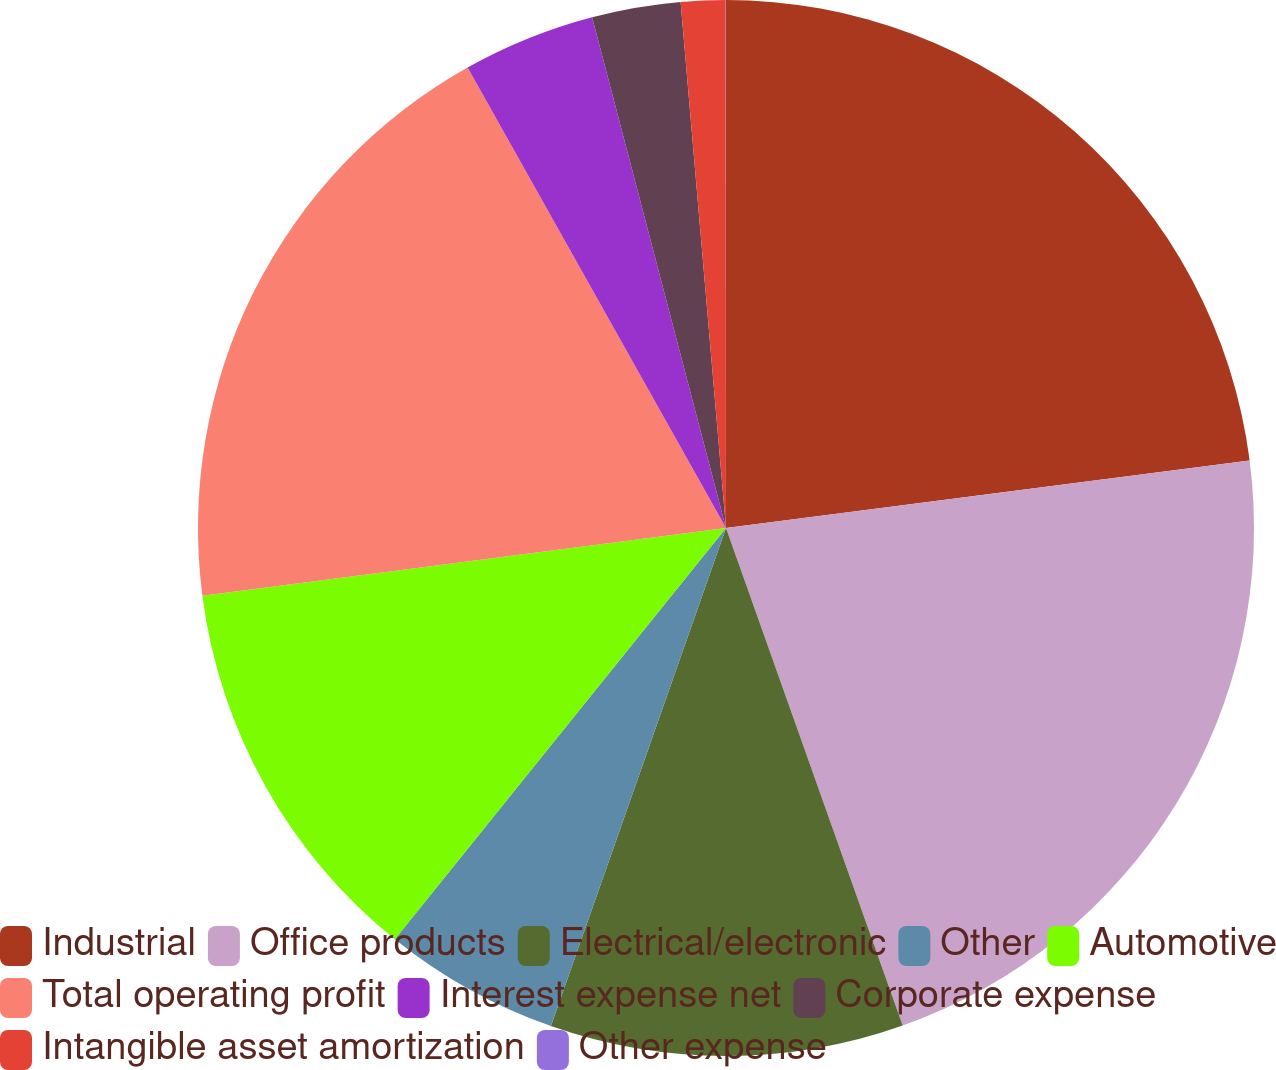<chart> <loc_0><loc_0><loc_500><loc_500><pie_chart><fcel>Industrial<fcel>Office products<fcel>Electrical/electronic<fcel>Other<fcel>Automotive<fcel>Total operating profit<fcel>Interest expense net<fcel>Corporate expense<fcel>Intangible asset amortization<fcel>Other expense<nl><fcel>22.96%<fcel>21.61%<fcel>10.81%<fcel>5.41%<fcel>12.16%<fcel>18.91%<fcel>4.06%<fcel>2.71%<fcel>1.36%<fcel>0.01%<nl></chart> 